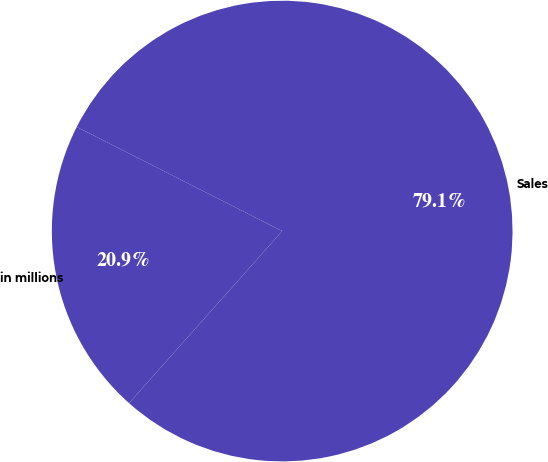<chart> <loc_0><loc_0><loc_500><loc_500><pie_chart><fcel>in millions<fcel>Sales<nl><fcel>20.89%<fcel>79.11%<nl></chart> 